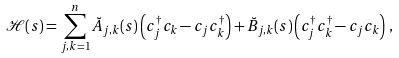Convert formula to latex. <formula><loc_0><loc_0><loc_500><loc_500>\mathcal { H } ( s ) = \sum _ { j , k = 1 } ^ { n } \breve { A } _ { j , k } ( s ) \left ( c _ { j } ^ { \dagger } c _ { k } - c _ { j } c _ { k } ^ { \dagger } \right ) + \breve { B } _ { j , k } ( s ) \left ( c _ { j } ^ { \dagger } c _ { k } ^ { \dagger } - c _ { j } c _ { k } \right ) \, ,</formula> 